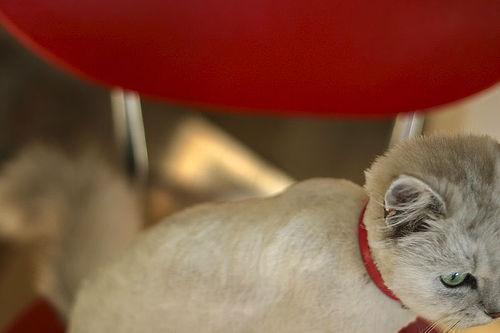How many cats are there?
Give a very brief answer. 1. How many keyboards are in the image?
Give a very brief answer. 0. 